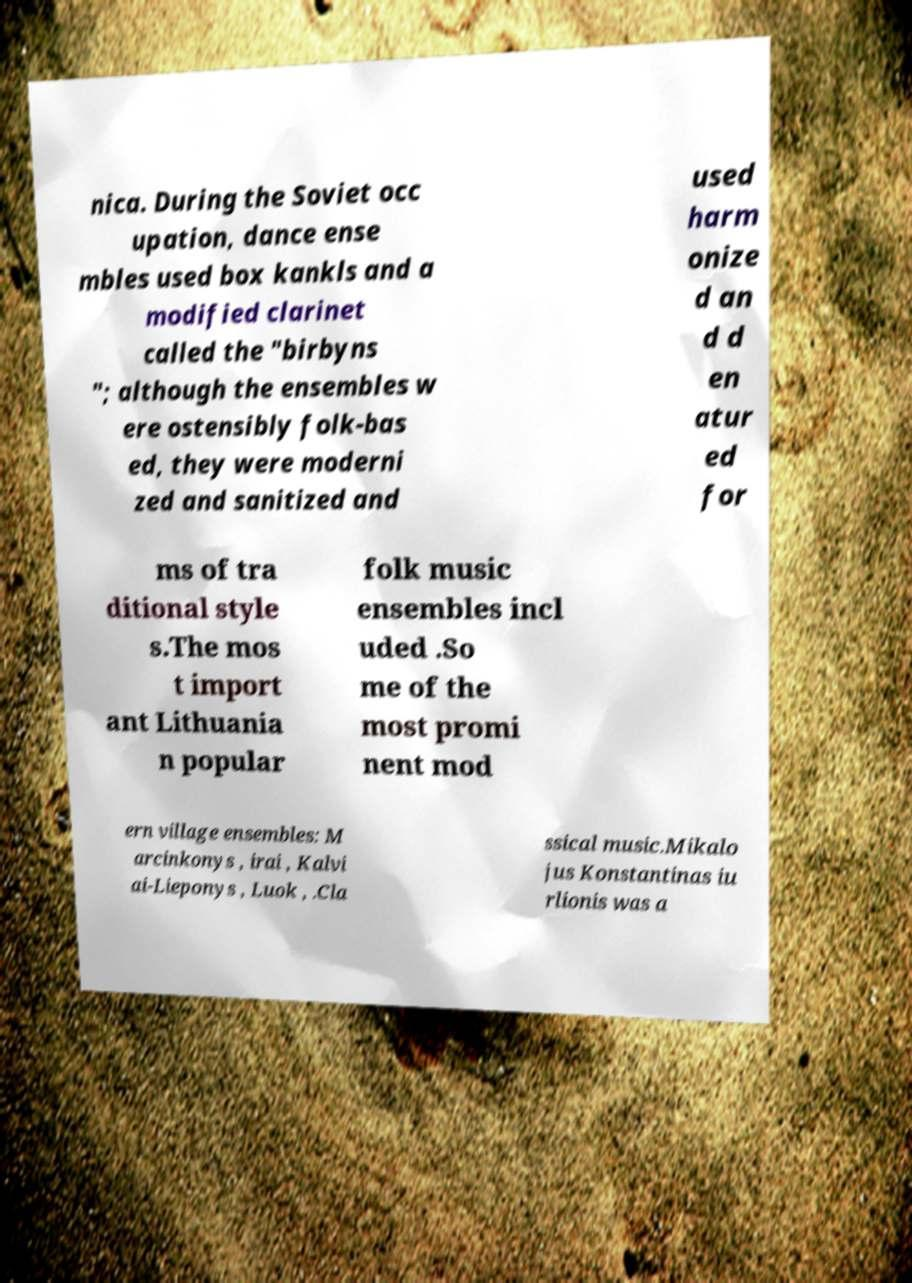For documentation purposes, I need the text within this image transcribed. Could you provide that? nica. During the Soviet occ upation, dance ense mbles used box kankls and a modified clarinet called the "birbyns "; although the ensembles w ere ostensibly folk-bas ed, they were moderni zed and sanitized and used harm onize d an d d en atur ed for ms of tra ditional style s.The mos t import ant Lithuania n popular folk music ensembles incl uded .So me of the most promi nent mod ern village ensembles: M arcinkonys , irai , Kalvi ai-Lieponys , Luok , .Cla ssical music.Mikalo jus Konstantinas iu rlionis was a 